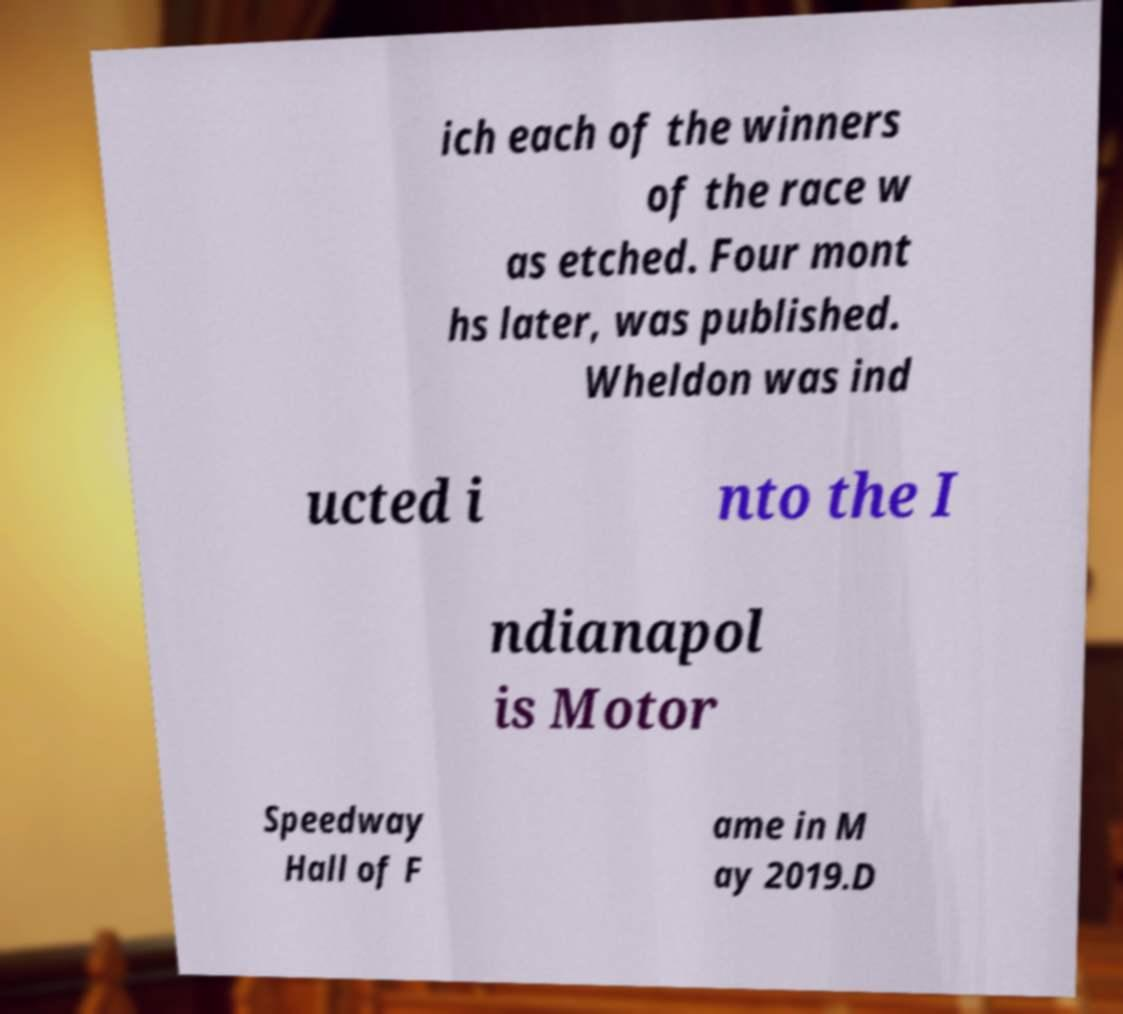Could you assist in decoding the text presented in this image and type it out clearly? ich each of the winners of the race w as etched. Four mont hs later, was published. Wheldon was ind ucted i nto the I ndianapol is Motor Speedway Hall of F ame in M ay 2019.D 